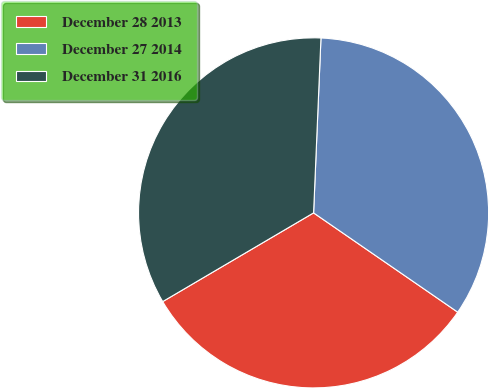<chart> <loc_0><loc_0><loc_500><loc_500><pie_chart><fcel>December 28 2013<fcel>December 27 2014<fcel>December 31 2016<nl><fcel>31.94%<fcel>33.93%<fcel>34.13%<nl></chart> 